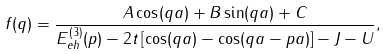Convert formula to latex. <formula><loc_0><loc_0><loc_500><loc_500>f ( q ) = \frac { A \cos ( q a ) + B \sin ( q a ) + C } { E ^ { ( 3 ) } _ { e h } ( p ) - 2 t \left [ \cos ( q a ) - \cos ( q a - p a ) \right ] - J - U } ,</formula> 